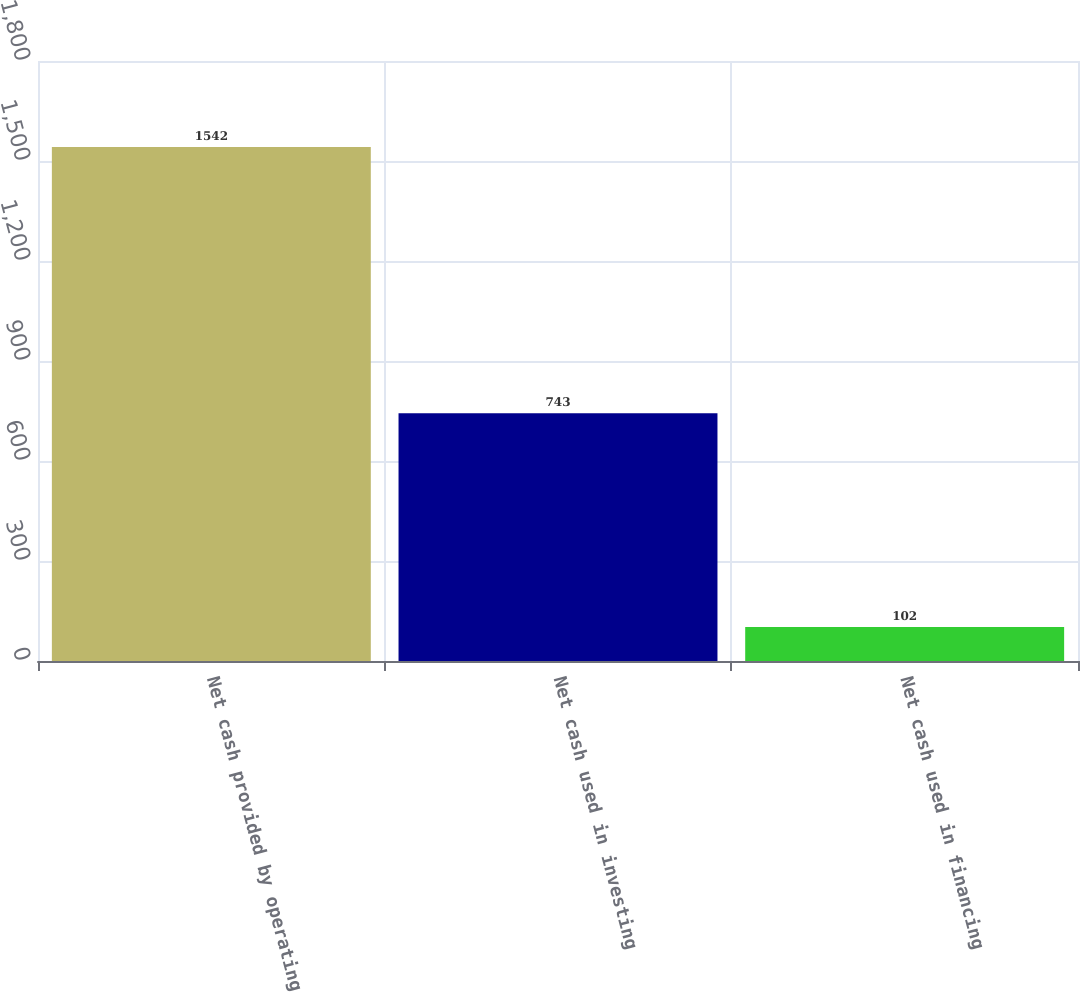<chart> <loc_0><loc_0><loc_500><loc_500><bar_chart><fcel>Net cash provided by operating<fcel>Net cash used in investing<fcel>Net cash used in financing<nl><fcel>1542<fcel>743<fcel>102<nl></chart> 